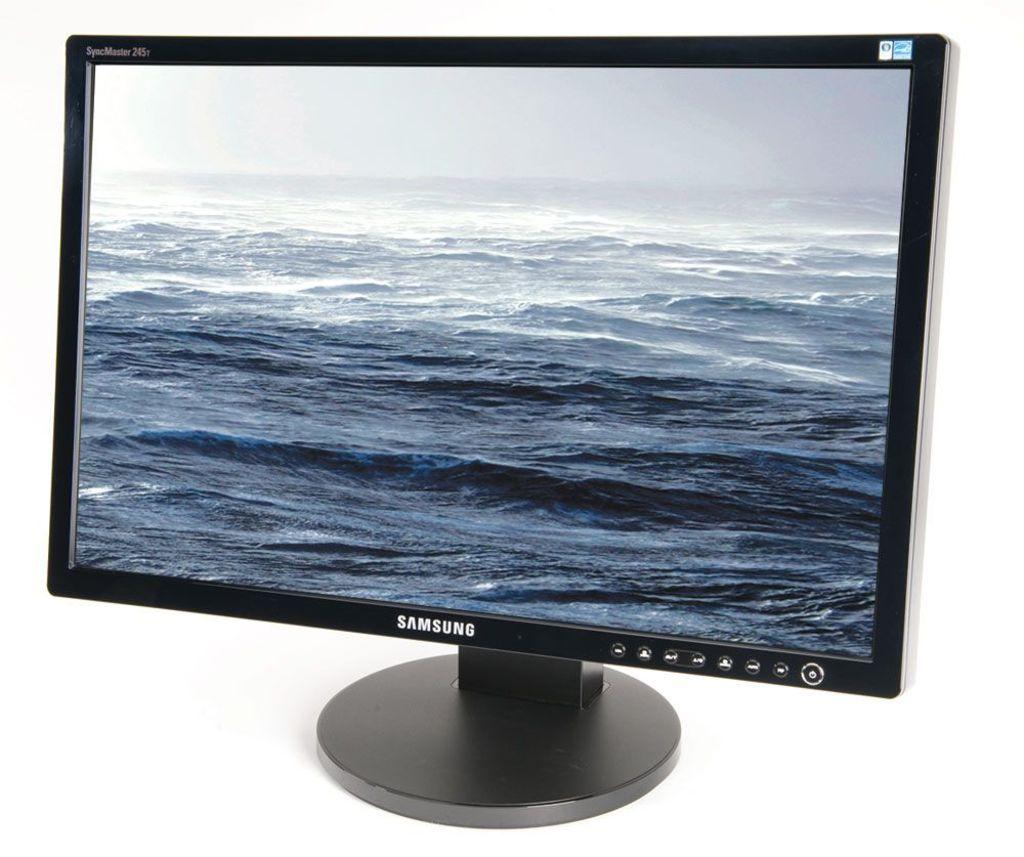Whos company logo is on the front of the monitor?
Provide a short and direct response. Samsung. 